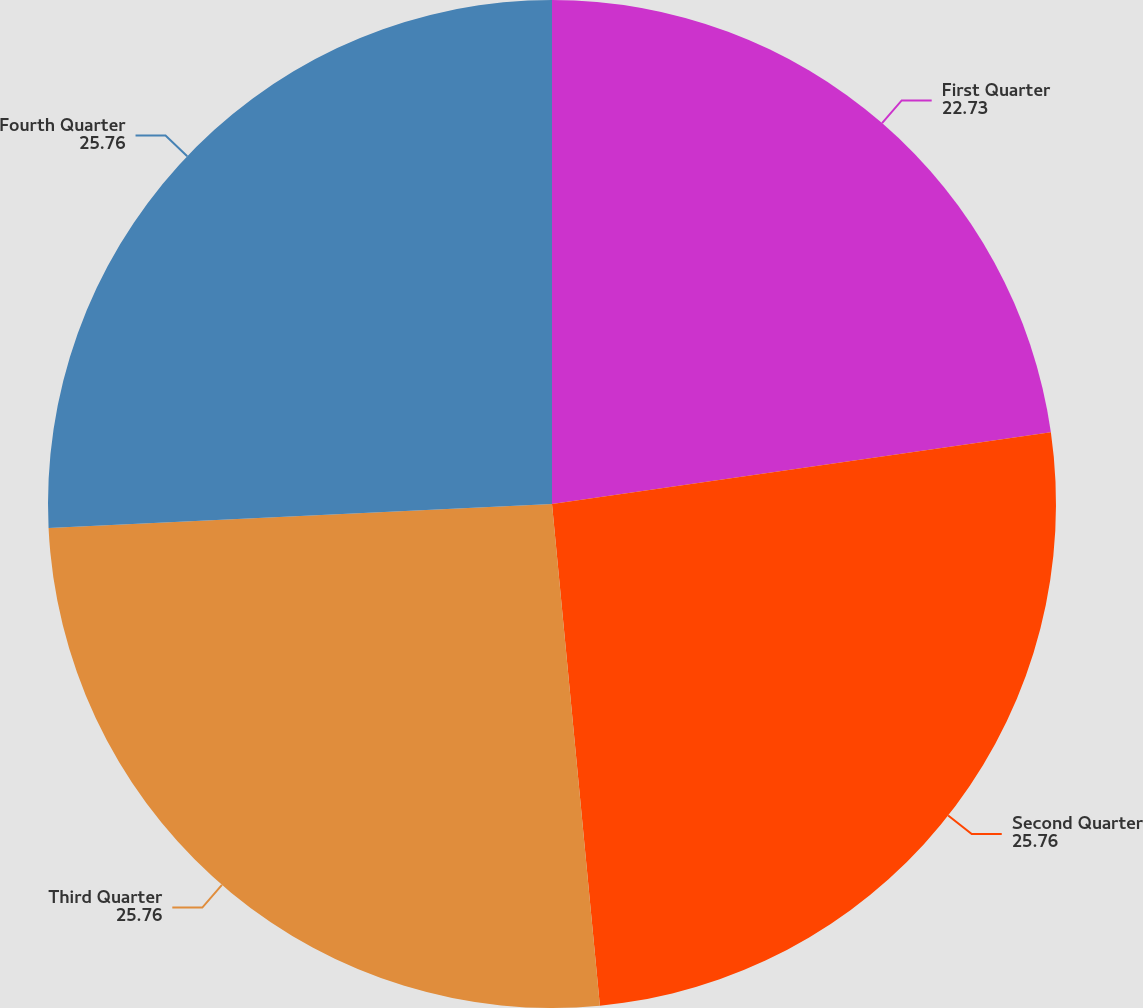<chart> <loc_0><loc_0><loc_500><loc_500><pie_chart><fcel>First Quarter<fcel>Second Quarter<fcel>Third Quarter<fcel>Fourth Quarter<nl><fcel>22.73%<fcel>25.76%<fcel>25.76%<fcel>25.76%<nl></chart> 